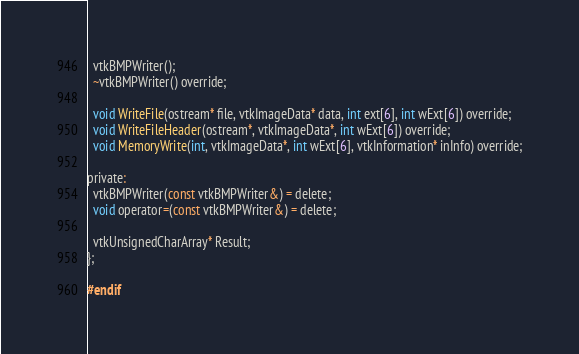Convert code to text. <code><loc_0><loc_0><loc_500><loc_500><_C_>  vtkBMPWriter();
  ~vtkBMPWriter() override;

  void WriteFile(ostream* file, vtkImageData* data, int ext[6], int wExt[6]) override;
  void WriteFileHeader(ostream*, vtkImageData*, int wExt[6]) override;
  void MemoryWrite(int, vtkImageData*, int wExt[6], vtkInformation* inInfo) override;

private:
  vtkBMPWriter(const vtkBMPWriter&) = delete;
  void operator=(const vtkBMPWriter&) = delete;

  vtkUnsignedCharArray* Result;
};

#endif
</code> 